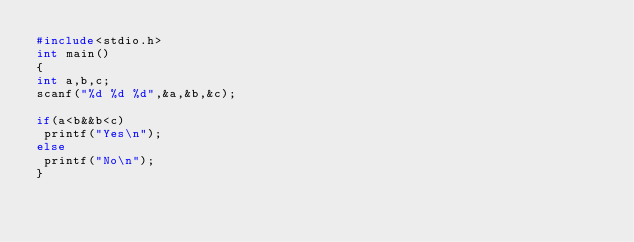<code> <loc_0><loc_0><loc_500><loc_500><_C_>#include<stdio.h>
int main()
{
int a,b,c;
scanf("%d %d %d",&a,&b,&c);

if(a<b&&b<c)
 printf("Yes\n");
else
 printf("No\n");
}</code> 